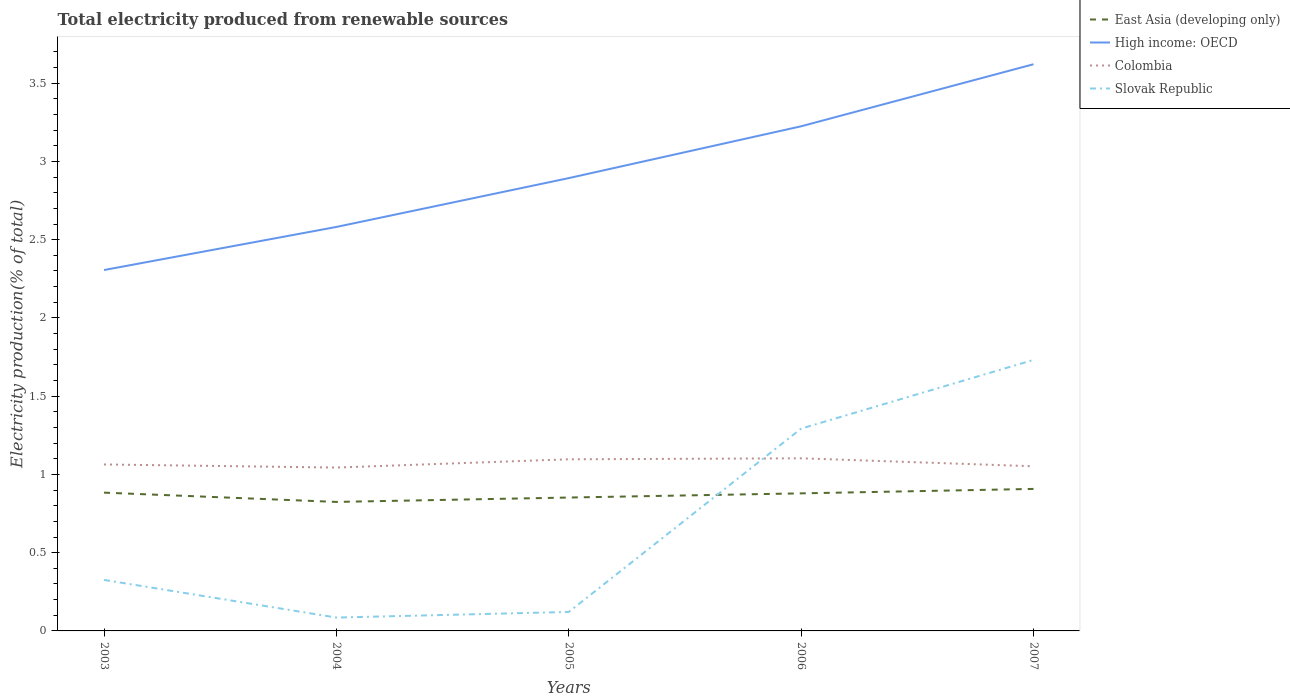Across all years, what is the maximum total electricity produced in Slovak Republic?
Your answer should be very brief. 0.09. What is the total total electricity produced in High income: OECD in the graph?
Offer a very short reply. -0.92. What is the difference between the highest and the second highest total electricity produced in Colombia?
Provide a succinct answer. 0.06. How many lines are there?
Ensure brevity in your answer.  4. What is the difference between two consecutive major ticks on the Y-axis?
Make the answer very short. 0.5. Are the values on the major ticks of Y-axis written in scientific E-notation?
Ensure brevity in your answer.  No. Does the graph contain any zero values?
Keep it short and to the point. No. How many legend labels are there?
Keep it short and to the point. 4. How are the legend labels stacked?
Offer a terse response. Vertical. What is the title of the graph?
Offer a terse response. Total electricity produced from renewable sources. Does "Argentina" appear as one of the legend labels in the graph?
Make the answer very short. No. What is the label or title of the Y-axis?
Provide a succinct answer. Electricity production(% of total). What is the Electricity production(% of total) in East Asia (developing only) in 2003?
Your response must be concise. 0.88. What is the Electricity production(% of total) in High income: OECD in 2003?
Your response must be concise. 2.31. What is the Electricity production(% of total) in Colombia in 2003?
Offer a terse response. 1.06. What is the Electricity production(% of total) of Slovak Republic in 2003?
Offer a very short reply. 0.33. What is the Electricity production(% of total) in East Asia (developing only) in 2004?
Offer a very short reply. 0.82. What is the Electricity production(% of total) of High income: OECD in 2004?
Ensure brevity in your answer.  2.58. What is the Electricity production(% of total) of Colombia in 2004?
Your answer should be very brief. 1.04. What is the Electricity production(% of total) in Slovak Republic in 2004?
Provide a short and direct response. 0.09. What is the Electricity production(% of total) of East Asia (developing only) in 2005?
Offer a terse response. 0.85. What is the Electricity production(% of total) of High income: OECD in 2005?
Keep it short and to the point. 2.89. What is the Electricity production(% of total) in Colombia in 2005?
Provide a short and direct response. 1.1. What is the Electricity production(% of total) of Slovak Republic in 2005?
Give a very brief answer. 0.12. What is the Electricity production(% of total) of East Asia (developing only) in 2006?
Ensure brevity in your answer.  0.88. What is the Electricity production(% of total) of High income: OECD in 2006?
Offer a very short reply. 3.22. What is the Electricity production(% of total) of Colombia in 2006?
Keep it short and to the point. 1.1. What is the Electricity production(% of total) in Slovak Republic in 2006?
Ensure brevity in your answer.  1.29. What is the Electricity production(% of total) in East Asia (developing only) in 2007?
Your response must be concise. 0.91. What is the Electricity production(% of total) of High income: OECD in 2007?
Keep it short and to the point. 3.62. What is the Electricity production(% of total) of Colombia in 2007?
Ensure brevity in your answer.  1.05. What is the Electricity production(% of total) of Slovak Republic in 2007?
Ensure brevity in your answer.  1.73. Across all years, what is the maximum Electricity production(% of total) in East Asia (developing only)?
Make the answer very short. 0.91. Across all years, what is the maximum Electricity production(% of total) of High income: OECD?
Your answer should be compact. 3.62. Across all years, what is the maximum Electricity production(% of total) in Colombia?
Your answer should be very brief. 1.1. Across all years, what is the maximum Electricity production(% of total) in Slovak Republic?
Your answer should be very brief. 1.73. Across all years, what is the minimum Electricity production(% of total) in East Asia (developing only)?
Give a very brief answer. 0.82. Across all years, what is the minimum Electricity production(% of total) in High income: OECD?
Your answer should be compact. 2.31. Across all years, what is the minimum Electricity production(% of total) of Colombia?
Offer a very short reply. 1.04. Across all years, what is the minimum Electricity production(% of total) of Slovak Republic?
Your answer should be compact. 0.09. What is the total Electricity production(% of total) in East Asia (developing only) in the graph?
Provide a succinct answer. 4.35. What is the total Electricity production(% of total) of High income: OECD in the graph?
Provide a short and direct response. 14.63. What is the total Electricity production(% of total) in Colombia in the graph?
Provide a short and direct response. 5.36. What is the total Electricity production(% of total) in Slovak Republic in the graph?
Your response must be concise. 3.56. What is the difference between the Electricity production(% of total) of East Asia (developing only) in 2003 and that in 2004?
Your answer should be compact. 0.06. What is the difference between the Electricity production(% of total) of High income: OECD in 2003 and that in 2004?
Your answer should be very brief. -0.28. What is the difference between the Electricity production(% of total) in Colombia in 2003 and that in 2004?
Make the answer very short. 0.02. What is the difference between the Electricity production(% of total) in Slovak Republic in 2003 and that in 2004?
Provide a short and direct response. 0.24. What is the difference between the Electricity production(% of total) of East Asia (developing only) in 2003 and that in 2005?
Give a very brief answer. 0.03. What is the difference between the Electricity production(% of total) of High income: OECD in 2003 and that in 2005?
Keep it short and to the point. -0.59. What is the difference between the Electricity production(% of total) in Colombia in 2003 and that in 2005?
Offer a terse response. -0.03. What is the difference between the Electricity production(% of total) in Slovak Republic in 2003 and that in 2005?
Make the answer very short. 0.2. What is the difference between the Electricity production(% of total) in East Asia (developing only) in 2003 and that in 2006?
Give a very brief answer. 0. What is the difference between the Electricity production(% of total) in High income: OECD in 2003 and that in 2006?
Offer a terse response. -0.92. What is the difference between the Electricity production(% of total) of Colombia in 2003 and that in 2006?
Offer a very short reply. -0.04. What is the difference between the Electricity production(% of total) of Slovak Republic in 2003 and that in 2006?
Your answer should be very brief. -0.97. What is the difference between the Electricity production(% of total) of East Asia (developing only) in 2003 and that in 2007?
Provide a succinct answer. -0.02. What is the difference between the Electricity production(% of total) of High income: OECD in 2003 and that in 2007?
Your answer should be compact. -1.31. What is the difference between the Electricity production(% of total) of Colombia in 2003 and that in 2007?
Give a very brief answer. 0.01. What is the difference between the Electricity production(% of total) in Slovak Republic in 2003 and that in 2007?
Offer a terse response. -1.41. What is the difference between the Electricity production(% of total) of East Asia (developing only) in 2004 and that in 2005?
Provide a short and direct response. -0.03. What is the difference between the Electricity production(% of total) in High income: OECD in 2004 and that in 2005?
Ensure brevity in your answer.  -0.31. What is the difference between the Electricity production(% of total) of Colombia in 2004 and that in 2005?
Make the answer very short. -0.05. What is the difference between the Electricity production(% of total) in Slovak Republic in 2004 and that in 2005?
Provide a succinct answer. -0.04. What is the difference between the Electricity production(% of total) in East Asia (developing only) in 2004 and that in 2006?
Ensure brevity in your answer.  -0.05. What is the difference between the Electricity production(% of total) of High income: OECD in 2004 and that in 2006?
Provide a succinct answer. -0.64. What is the difference between the Electricity production(% of total) in Colombia in 2004 and that in 2006?
Keep it short and to the point. -0.06. What is the difference between the Electricity production(% of total) in Slovak Republic in 2004 and that in 2006?
Offer a terse response. -1.21. What is the difference between the Electricity production(% of total) in East Asia (developing only) in 2004 and that in 2007?
Your answer should be very brief. -0.08. What is the difference between the Electricity production(% of total) in High income: OECD in 2004 and that in 2007?
Your answer should be very brief. -1.04. What is the difference between the Electricity production(% of total) in Colombia in 2004 and that in 2007?
Offer a very short reply. -0.01. What is the difference between the Electricity production(% of total) of Slovak Republic in 2004 and that in 2007?
Provide a succinct answer. -1.65. What is the difference between the Electricity production(% of total) of East Asia (developing only) in 2005 and that in 2006?
Offer a terse response. -0.03. What is the difference between the Electricity production(% of total) in High income: OECD in 2005 and that in 2006?
Make the answer very short. -0.33. What is the difference between the Electricity production(% of total) in Colombia in 2005 and that in 2006?
Offer a terse response. -0.01. What is the difference between the Electricity production(% of total) in Slovak Republic in 2005 and that in 2006?
Provide a succinct answer. -1.17. What is the difference between the Electricity production(% of total) of East Asia (developing only) in 2005 and that in 2007?
Provide a succinct answer. -0.06. What is the difference between the Electricity production(% of total) in High income: OECD in 2005 and that in 2007?
Your answer should be very brief. -0.73. What is the difference between the Electricity production(% of total) of Colombia in 2005 and that in 2007?
Provide a succinct answer. 0.04. What is the difference between the Electricity production(% of total) in Slovak Republic in 2005 and that in 2007?
Make the answer very short. -1.61. What is the difference between the Electricity production(% of total) of East Asia (developing only) in 2006 and that in 2007?
Your answer should be compact. -0.03. What is the difference between the Electricity production(% of total) in High income: OECD in 2006 and that in 2007?
Give a very brief answer. -0.4. What is the difference between the Electricity production(% of total) of Colombia in 2006 and that in 2007?
Make the answer very short. 0.05. What is the difference between the Electricity production(% of total) of Slovak Republic in 2006 and that in 2007?
Provide a short and direct response. -0.44. What is the difference between the Electricity production(% of total) in East Asia (developing only) in 2003 and the Electricity production(% of total) in High income: OECD in 2004?
Ensure brevity in your answer.  -1.7. What is the difference between the Electricity production(% of total) of East Asia (developing only) in 2003 and the Electricity production(% of total) of Colombia in 2004?
Provide a short and direct response. -0.16. What is the difference between the Electricity production(% of total) of East Asia (developing only) in 2003 and the Electricity production(% of total) of Slovak Republic in 2004?
Give a very brief answer. 0.8. What is the difference between the Electricity production(% of total) in High income: OECD in 2003 and the Electricity production(% of total) in Colombia in 2004?
Give a very brief answer. 1.26. What is the difference between the Electricity production(% of total) in High income: OECD in 2003 and the Electricity production(% of total) in Slovak Republic in 2004?
Make the answer very short. 2.22. What is the difference between the Electricity production(% of total) of Colombia in 2003 and the Electricity production(% of total) of Slovak Republic in 2004?
Your answer should be compact. 0.98. What is the difference between the Electricity production(% of total) in East Asia (developing only) in 2003 and the Electricity production(% of total) in High income: OECD in 2005?
Give a very brief answer. -2.01. What is the difference between the Electricity production(% of total) of East Asia (developing only) in 2003 and the Electricity production(% of total) of Colombia in 2005?
Offer a terse response. -0.21. What is the difference between the Electricity production(% of total) of East Asia (developing only) in 2003 and the Electricity production(% of total) of Slovak Republic in 2005?
Offer a very short reply. 0.76. What is the difference between the Electricity production(% of total) of High income: OECD in 2003 and the Electricity production(% of total) of Colombia in 2005?
Keep it short and to the point. 1.21. What is the difference between the Electricity production(% of total) in High income: OECD in 2003 and the Electricity production(% of total) in Slovak Republic in 2005?
Your response must be concise. 2.18. What is the difference between the Electricity production(% of total) of Colombia in 2003 and the Electricity production(% of total) of Slovak Republic in 2005?
Keep it short and to the point. 0.94. What is the difference between the Electricity production(% of total) of East Asia (developing only) in 2003 and the Electricity production(% of total) of High income: OECD in 2006?
Your response must be concise. -2.34. What is the difference between the Electricity production(% of total) of East Asia (developing only) in 2003 and the Electricity production(% of total) of Colombia in 2006?
Your response must be concise. -0.22. What is the difference between the Electricity production(% of total) in East Asia (developing only) in 2003 and the Electricity production(% of total) in Slovak Republic in 2006?
Ensure brevity in your answer.  -0.41. What is the difference between the Electricity production(% of total) in High income: OECD in 2003 and the Electricity production(% of total) in Colombia in 2006?
Offer a very short reply. 1.2. What is the difference between the Electricity production(% of total) of High income: OECD in 2003 and the Electricity production(% of total) of Slovak Republic in 2006?
Your answer should be very brief. 1.01. What is the difference between the Electricity production(% of total) of Colombia in 2003 and the Electricity production(% of total) of Slovak Republic in 2006?
Provide a succinct answer. -0.23. What is the difference between the Electricity production(% of total) of East Asia (developing only) in 2003 and the Electricity production(% of total) of High income: OECD in 2007?
Provide a short and direct response. -2.74. What is the difference between the Electricity production(% of total) of East Asia (developing only) in 2003 and the Electricity production(% of total) of Colombia in 2007?
Keep it short and to the point. -0.17. What is the difference between the Electricity production(% of total) in East Asia (developing only) in 2003 and the Electricity production(% of total) in Slovak Republic in 2007?
Provide a succinct answer. -0.85. What is the difference between the Electricity production(% of total) in High income: OECD in 2003 and the Electricity production(% of total) in Colombia in 2007?
Provide a succinct answer. 1.25. What is the difference between the Electricity production(% of total) of High income: OECD in 2003 and the Electricity production(% of total) of Slovak Republic in 2007?
Give a very brief answer. 0.57. What is the difference between the Electricity production(% of total) of Colombia in 2003 and the Electricity production(% of total) of Slovak Republic in 2007?
Your answer should be compact. -0.67. What is the difference between the Electricity production(% of total) of East Asia (developing only) in 2004 and the Electricity production(% of total) of High income: OECD in 2005?
Your answer should be compact. -2.07. What is the difference between the Electricity production(% of total) in East Asia (developing only) in 2004 and the Electricity production(% of total) in Colombia in 2005?
Provide a succinct answer. -0.27. What is the difference between the Electricity production(% of total) of East Asia (developing only) in 2004 and the Electricity production(% of total) of Slovak Republic in 2005?
Offer a terse response. 0.7. What is the difference between the Electricity production(% of total) of High income: OECD in 2004 and the Electricity production(% of total) of Colombia in 2005?
Keep it short and to the point. 1.48. What is the difference between the Electricity production(% of total) of High income: OECD in 2004 and the Electricity production(% of total) of Slovak Republic in 2005?
Your answer should be very brief. 2.46. What is the difference between the Electricity production(% of total) of Colombia in 2004 and the Electricity production(% of total) of Slovak Republic in 2005?
Provide a succinct answer. 0.92. What is the difference between the Electricity production(% of total) in East Asia (developing only) in 2004 and the Electricity production(% of total) in High income: OECD in 2006?
Provide a succinct answer. -2.4. What is the difference between the Electricity production(% of total) in East Asia (developing only) in 2004 and the Electricity production(% of total) in Colombia in 2006?
Your answer should be compact. -0.28. What is the difference between the Electricity production(% of total) in East Asia (developing only) in 2004 and the Electricity production(% of total) in Slovak Republic in 2006?
Provide a succinct answer. -0.47. What is the difference between the Electricity production(% of total) in High income: OECD in 2004 and the Electricity production(% of total) in Colombia in 2006?
Your answer should be compact. 1.48. What is the difference between the Electricity production(% of total) in High income: OECD in 2004 and the Electricity production(% of total) in Slovak Republic in 2006?
Your response must be concise. 1.29. What is the difference between the Electricity production(% of total) of Colombia in 2004 and the Electricity production(% of total) of Slovak Republic in 2006?
Make the answer very short. -0.25. What is the difference between the Electricity production(% of total) of East Asia (developing only) in 2004 and the Electricity production(% of total) of High income: OECD in 2007?
Offer a terse response. -2.8. What is the difference between the Electricity production(% of total) of East Asia (developing only) in 2004 and the Electricity production(% of total) of Colombia in 2007?
Your answer should be very brief. -0.23. What is the difference between the Electricity production(% of total) of East Asia (developing only) in 2004 and the Electricity production(% of total) of Slovak Republic in 2007?
Ensure brevity in your answer.  -0.91. What is the difference between the Electricity production(% of total) in High income: OECD in 2004 and the Electricity production(% of total) in Colombia in 2007?
Make the answer very short. 1.53. What is the difference between the Electricity production(% of total) in High income: OECD in 2004 and the Electricity production(% of total) in Slovak Republic in 2007?
Make the answer very short. 0.85. What is the difference between the Electricity production(% of total) of Colombia in 2004 and the Electricity production(% of total) of Slovak Republic in 2007?
Provide a short and direct response. -0.69. What is the difference between the Electricity production(% of total) of East Asia (developing only) in 2005 and the Electricity production(% of total) of High income: OECD in 2006?
Your response must be concise. -2.37. What is the difference between the Electricity production(% of total) in East Asia (developing only) in 2005 and the Electricity production(% of total) in Colombia in 2006?
Your response must be concise. -0.25. What is the difference between the Electricity production(% of total) of East Asia (developing only) in 2005 and the Electricity production(% of total) of Slovak Republic in 2006?
Your response must be concise. -0.44. What is the difference between the Electricity production(% of total) of High income: OECD in 2005 and the Electricity production(% of total) of Colombia in 2006?
Ensure brevity in your answer.  1.79. What is the difference between the Electricity production(% of total) in High income: OECD in 2005 and the Electricity production(% of total) in Slovak Republic in 2006?
Provide a short and direct response. 1.6. What is the difference between the Electricity production(% of total) in Colombia in 2005 and the Electricity production(% of total) in Slovak Republic in 2006?
Ensure brevity in your answer.  -0.2. What is the difference between the Electricity production(% of total) of East Asia (developing only) in 2005 and the Electricity production(% of total) of High income: OECD in 2007?
Provide a short and direct response. -2.77. What is the difference between the Electricity production(% of total) of East Asia (developing only) in 2005 and the Electricity production(% of total) of Colombia in 2007?
Provide a short and direct response. -0.2. What is the difference between the Electricity production(% of total) of East Asia (developing only) in 2005 and the Electricity production(% of total) of Slovak Republic in 2007?
Your response must be concise. -0.88. What is the difference between the Electricity production(% of total) of High income: OECD in 2005 and the Electricity production(% of total) of Colombia in 2007?
Provide a succinct answer. 1.84. What is the difference between the Electricity production(% of total) of High income: OECD in 2005 and the Electricity production(% of total) of Slovak Republic in 2007?
Offer a terse response. 1.16. What is the difference between the Electricity production(% of total) in Colombia in 2005 and the Electricity production(% of total) in Slovak Republic in 2007?
Your response must be concise. -0.64. What is the difference between the Electricity production(% of total) in East Asia (developing only) in 2006 and the Electricity production(% of total) in High income: OECD in 2007?
Offer a terse response. -2.74. What is the difference between the Electricity production(% of total) in East Asia (developing only) in 2006 and the Electricity production(% of total) in Colombia in 2007?
Your response must be concise. -0.17. What is the difference between the Electricity production(% of total) of East Asia (developing only) in 2006 and the Electricity production(% of total) of Slovak Republic in 2007?
Give a very brief answer. -0.85. What is the difference between the Electricity production(% of total) of High income: OECD in 2006 and the Electricity production(% of total) of Colombia in 2007?
Your answer should be compact. 2.17. What is the difference between the Electricity production(% of total) in High income: OECD in 2006 and the Electricity production(% of total) in Slovak Republic in 2007?
Offer a terse response. 1.49. What is the difference between the Electricity production(% of total) of Colombia in 2006 and the Electricity production(% of total) of Slovak Republic in 2007?
Your response must be concise. -0.63. What is the average Electricity production(% of total) of East Asia (developing only) per year?
Your answer should be compact. 0.87. What is the average Electricity production(% of total) in High income: OECD per year?
Give a very brief answer. 2.93. What is the average Electricity production(% of total) in Colombia per year?
Keep it short and to the point. 1.07. What is the average Electricity production(% of total) in Slovak Republic per year?
Offer a very short reply. 0.71. In the year 2003, what is the difference between the Electricity production(% of total) of East Asia (developing only) and Electricity production(% of total) of High income: OECD?
Your response must be concise. -1.42. In the year 2003, what is the difference between the Electricity production(% of total) in East Asia (developing only) and Electricity production(% of total) in Colombia?
Offer a terse response. -0.18. In the year 2003, what is the difference between the Electricity production(% of total) in East Asia (developing only) and Electricity production(% of total) in Slovak Republic?
Make the answer very short. 0.56. In the year 2003, what is the difference between the Electricity production(% of total) in High income: OECD and Electricity production(% of total) in Colombia?
Provide a succinct answer. 1.24. In the year 2003, what is the difference between the Electricity production(% of total) in High income: OECD and Electricity production(% of total) in Slovak Republic?
Your response must be concise. 1.98. In the year 2003, what is the difference between the Electricity production(% of total) in Colombia and Electricity production(% of total) in Slovak Republic?
Your answer should be compact. 0.74. In the year 2004, what is the difference between the Electricity production(% of total) of East Asia (developing only) and Electricity production(% of total) of High income: OECD?
Provide a succinct answer. -1.76. In the year 2004, what is the difference between the Electricity production(% of total) in East Asia (developing only) and Electricity production(% of total) in Colombia?
Give a very brief answer. -0.22. In the year 2004, what is the difference between the Electricity production(% of total) in East Asia (developing only) and Electricity production(% of total) in Slovak Republic?
Offer a terse response. 0.74. In the year 2004, what is the difference between the Electricity production(% of total) of High income: OECD and Electricity production(% of total) of Colombia?
Keep it short and to the point. 1.54. In the year 2004, what is the difference between the Electricity production(% of total) of High income: OECD and Electricity production(% of total) of Slovak Republic?
Give a very brief answer. 2.5. In the year 2004, what is the difference between the Electricity production(% of total) in Colombia and Electricity production(% of total) in Slovak Republic?
Provide a succinct answer. 0.96. In the year 2005, what is the difference between the Electricity production(% of total) of East Asia (developing only) and Electricity production(% of total) of High income: OECD?
Your response must be concise. -2.04. In the year 2005, what is the difference between the Electricity production(% of total) of East Asia (developing only) and Electricity production(% of total) of Colombia?
Keep it short and to the point. -0.24. In the year 2005, what is the difference between the Electricity production(% of total) of East Asia (developing only) and Electricity production(% of total) of Slovak Republic?
Your answer should be compact. 0.73. In the year 2005, what is the difference between the Electricity production(% of total) of High income: OECD and Electricity production(% of total) of Colombia?
Ensure brevity in your answer.  1.8. In the year 2005, what is the difference between the Electricity production(% of total) of High income: OECD and Electricity production(% of total) of Slovak Republic?
Keep it short and to the point. 2.77. In the year 2005, what is the difference between the Electricity production(% of total) in Colombia and Electricity production(% of total) in Slovak Republic?
Offer a terse response. 0.98. In the year 2006, what is the difference between the Electricity production(% of total) of East Asia (developing only) and Electricity production(% of total) of High income: OECD?
Your response must be concise. -2.35. In the year 2006, what is the difference between the Electricity production(% of total) in East Asia (developing only) and Electricity production(% of total) in Colombia?
Make the answer very short. -0.22. In the year 2006, what is the difference between the Electricity production(% of total) in East Asia (developing only) and Electricity production(% of total) in Slovak Republic?
Give a very brief answer. -0.41. In the year 2006, what is the difference between the Electricity production(% of total) in High income: OECD and Electricity production(% of total) in Colombia?
Your response must be concise. 2.12. In the year 2006, what is the difference between the Electricity production(% of total) in High income: OECD and Electricity production(% of total) in Slovak Republic?
Offer a terse response. 1.93. In the year 2006, what is the difference between the Electricity production(% of total) in Colombia and Electricity production(% of total) in Slovak Republic?
Give a very brief answer. -0.19. In the year 2007, what is the difference between the Electricity production(% of total) of East Asia (developing only) and Electricity production(% of total) of High income: OECD?
Your response must be concise. -2.71. In the year 2007, what is the difference between the Electricity production(% of total) of East Asia (developing only) and Electricity production(% of total) of Colombia?
Offer a very short reply. -0.14. In the year 2007, what is the difference between the Electricity production(% of total) of East Asia (developing only) and Electricity production(% of total) of Slovak Republic?
Ensure brevity in your answer.  -0.82. In the year 2007, what is the difference between the Electricity production(% of total) of High income: OECD and Electricity production(% of total) of Colombia?
Ensure brevity in your answer.  2.57. In the year 2007, what is the difference between the Electricity production(% of total) in High income: OECD and Electricity production(% of total) in Slovak Republic?
Your response must be concise. 1.89. In the year 2007, what is the difference between the Electricity production(% of total) of Colombia and Electricity production(% of total) of Slovak Republic?
Offer a very short reply. -0.68. What is the ratio of the Electricity production(% of total) of East Asia (developing only) in 2003 to that in 2004?
Your answer should be very brief. 1.07. What is the ratio of the Electricity production(% of total) in High income: OECD in 2003 to that in 2004?
Keep it short and to the point. 0.89. What is the ratio of the Electricity production(% of total) in Colombia in 2003 to that in 2004?
Your answer should be very brief. 1.02. What is the ratio of the Electricity production(% of total) in Slovak Republic in 2003 to that in 2004?
Your response must be concise. 3.82. What is the ratio of the Electricity production(% of total) of East Asia (developing only) in 2003 to that in 2005?
Ensure brevity in your answer.  1.04. What is the ratio of the Electricity production(% of total) of High income: OECD in 2003 to that in 2005?
Keep it short and to the point. 0.8. What is the ratio of the Electricity production(% of total) of Colombia in 2003 to that in 2005?
Provide a succinct answer. 0.97. What is the ratio of the Electricity production(% of total) in Slovak Republic in 2003 to that in 2005?
Provide a short and direct response. 2.69. What is the ratio of the Electricity production(% of total) in High income: OECD in 2003 to that in 2006?
Your response must be concise. 0.72. What is the ratio of the Electricity production(% of total) of Slovak Republic in 2003 to that in 2006?
Your answer should be compact. 0.25. What is the ratio of the Electricity production(% of total) in East Asia (developing only) in 2003 to that in 2007?
Your answer should be very brief. 0.97. What is the ratio of the Electricity production(% of total) of High income: OECD in 2003 to that in 2007?
Offer a very short reply. 0.64. What is the ratio of the Electricity production(% of total) of Colombia in 2003 to that in 2007?
Ensure brevity in your answer.  1.01. What is the ratio of the Electricity production(% of total) of Slovak Republic in 2003 to that in 2007?
Keep it short and to the point. 0.19. What is the ratio of the Electricity production(% of total) in East Asia (developing only) in 2004 to that in 2005?
Keep it short and to the point. 0.97. What is the ratio of the Electricity production(% of total) of High income: OECD in 2004 to that in 2005?
Provide a succinct answer. 0.89. What is the ratio of the Electricity production(% of total) of Colombia in 2004 to that in 2005?
Ensure brevity in your answer.  0.95. What is the ratio of the Electricity production(% of total) in Slovak Republic in 2004 to that in 2005?
Provide a short and direct response. 0.7. What is the ratio of the Electricity production(% of total) in East Asia (developing only) in 2004 to that in 2006?
Provide a short and direct response. 0.94. What is the ratio of the Electricity production(% of total) of High income: OECD in 2004 to that in 2006?
Provide a succinct answer. 0.8. What is the ratio of the Electricity production(% of total) of Colombia in 2004 to that in 2006?
Your answer should be compact. 0.95. What is the ratio of the Electricity production(% of total) of Slovak Republic in 2004 to that in 2006?
Offer a terse response. 0.07. What is the ratio of the Electricity production(% of total) of East Asia (developing only) in 2004 to that in 2007?
Offer a terse response. 0.91. What is the ratio of the Electricity production(% of total) of High income: OECD in 2004 to that in 2007?
Your response must be concise. 0.71. What is the ratio of the Electricity production(% of total) in Slovak Republic in 2004 to that in 2007?
Ensure brevity in your answer.  0.05. What is the ratio of the Electricity production(% of total) of East Asia (developing only) in 2005 to that in 2006?
Keep it short and to the point. 0.97. What is the ratio of the Electricity production(% of total) in High income: OECD in 2005 to that in 2006?
Keep it short and to the point. 0.9. What is the ratio of the Electricity production(% of total) of Slovak Republic in 2005 to that in 2006?
Offer a very short reply. 0.09. What is the ratio of the Electricity production(% of total) in East Asia (developing only) in 2005 to that in 2007?
Provide a short and direct response. 0.94. What is the ratio of the Electricity production(% of total) in High income: OECD in 2005 to that in 2007?
Provide a succinct answer. 0.8. What is the ratio of the Electricity production(% of total) of Colombia in 2005 to that in 2007?
Give a very brief answer. 1.04. What is the ratio of the Electricity production(% of total) of Slovak Republic in 2005 to that in 2007?
Keep it short and to the point. 0.07. What is the ratio of the Electricity production(% of total) of East Asia (developing only) in 2006 to that in 2007?
Your answer should be very brief. 0.97. What is the ratio of the Electricity production(% of total) in High income: OECD in 2006 to that in 2007?
Your answer should be very brief. 0.89. What is the ratio of the Electricity production(% of total) of Colombia in 2006 to that in 2007?
Your answer should be very brief. 1.05. What is the ratio of the Electricity production(% of total) in Slovak Republic in 2006 to that in 2007?
Give a very brief answer. 0.75. What is the difference between the highest and the second highest Electricity production(% of total) of East Asia (developing only)?
Ensure brevity in your answer.  0.02. What is the difference between the highest and the second highest Electricity production(% of total) in High income: OECD?
Ensure brevity in your answer.  0.4. What is the difference between the highest and the second highest Electricity production(% of total) in Colombia?
Provide a succinct answer. 0.01. What is the difference between the highest and the second highest Electricity production(% of total) of Slovak Republic?
Ensure brevity in your answer.  0.44. What is the difference between the highest and the lowest Electricity production(% of total) in East Asia (developing only)?
Ensure brevity in your answer.  0.08. What is the difference between the highest and the lowest Electricity production(% of total) of High income: OECD?
Provide a succinct answer. 1.31. What is the difference between the highest and the lowest Electricity production(% of total) of Colombia?
Your answer should be compact. 0.06. What is the difference between the highest and the lowest Electricity production(% of total) of Slovak Republic?
Offer a terse response. 1.65. 